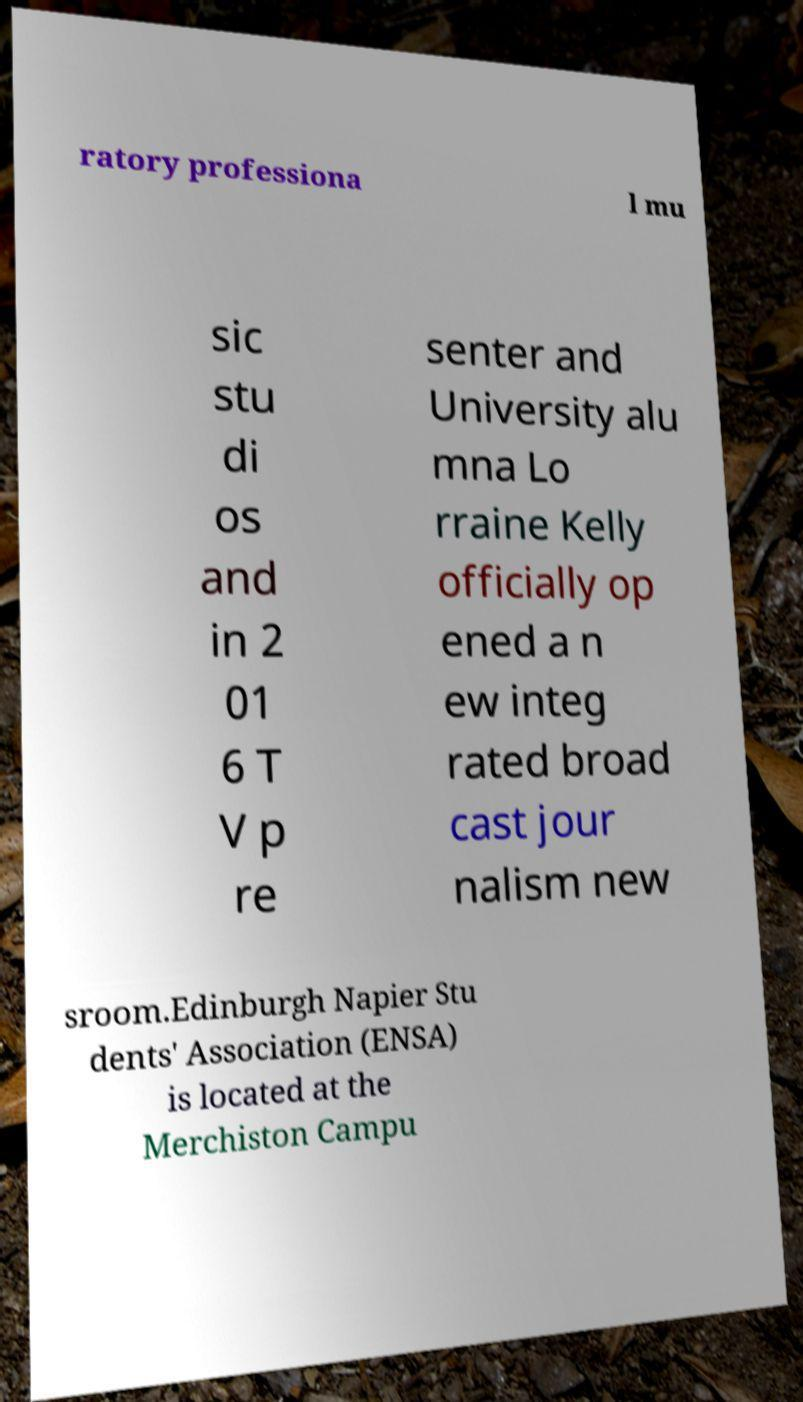Could you extract and type out the text from this image? ratory professiona l mu sic stu di os and in 2 01 6 T V p re senter and University alu mna Lo rraine Kelly officially op ened a n ew integ rated broad cast jour nalism new sroom.Edinburgh Napier Stu dents' Association (ENSA) is located at the Merchiston Campu 